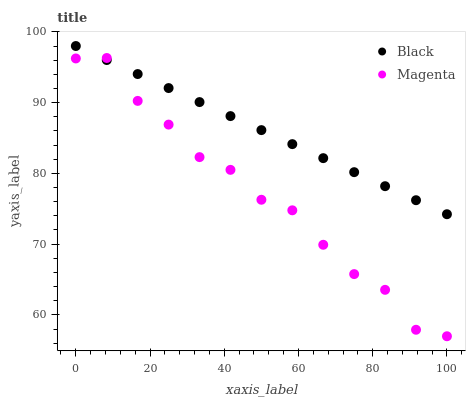Does Magenta have the minimum area under the curve?
Answer yes or no. Yes. Does Black have the maximum area under the curve?
Answer yes or no. Yes. Does Black have the minimum area under the curve?
Answer yes or no. No. Is Black the smoothest?
Answer yes or no. Yes. Is Magenta the roughest?
Answer yes or no. Yes. Is Black the roughest?
Answer yes or no. No. Does Magenta have the lowest value?
Answer yes or no. Yes. Does Black have the lowest value?
Answer yes or no. No. Does Black have the highest value?
Answer yes or no. Yes. Does Magenta intersect Black?
Answer yes or no. Yes. Is Magenta less than Black?
Answer yes or no. No. Is Magenta greater than Black?
Answer yes or no. No. 